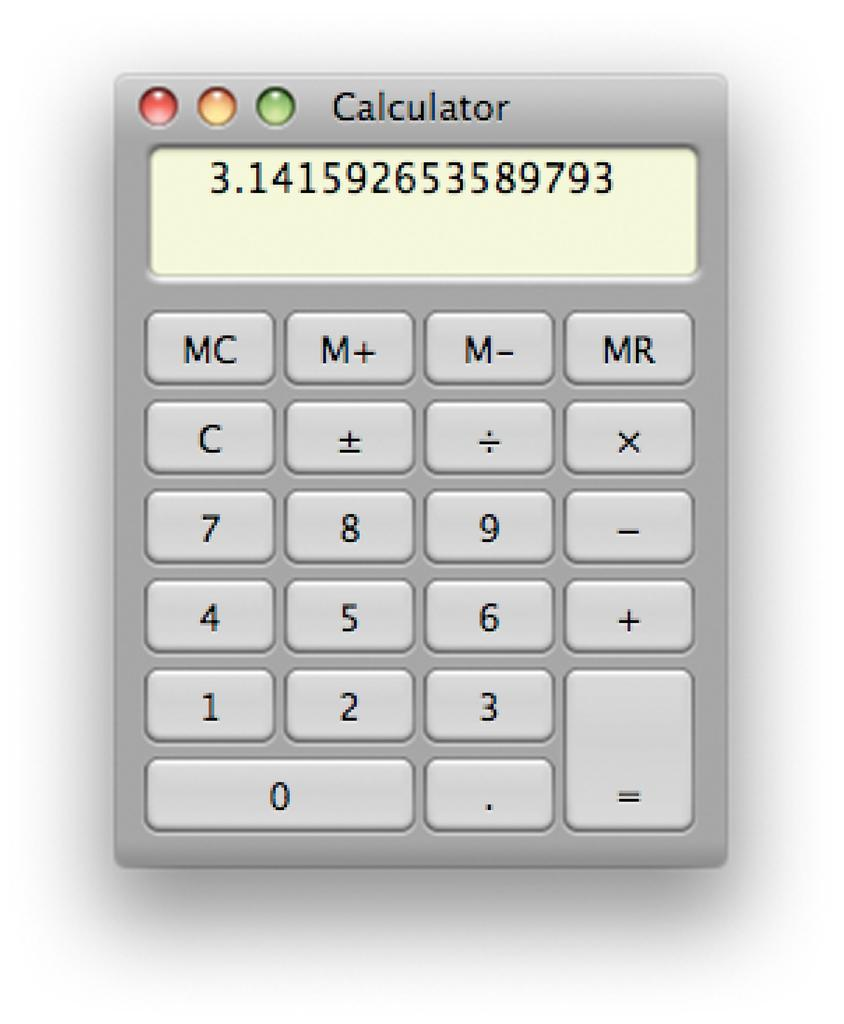<image>
Present a compact description of the photo's key features. A calculator program with pi displayed on the screen. 